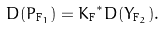Convert formula to latex. <formula><loc_0><loc_0><loc_500><loc_500>D ( P _ { { \tt F } _ { 1 } } ) = { K _ { \tt F } } ^ { * } D ( Y _ { { \tt F } _ { 2 } } ) .</formula> 